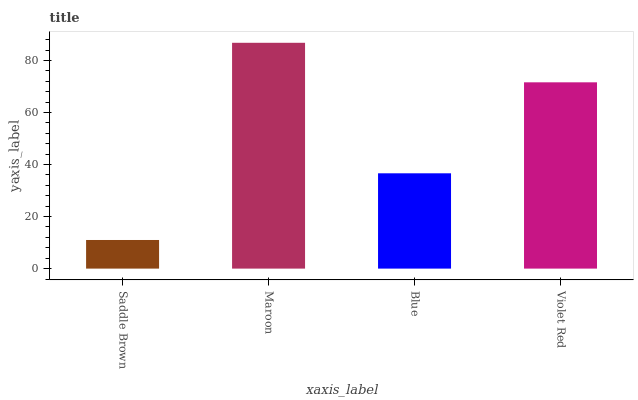Is Blue the minimum?
Answer yes or no. No. Is Blue the maximum?
Answer yes or no. No. Is Maroon greater than Blue?
Answer yes or no. Yes. Is Blue less than Maroon?
Answer yes or no. Yes. Is Blue greater than Maroon?
Answer yes or no. No. Is Maroon less than Blue?
Answer yes or no. No. Is Violet Red the high median?
Answer yes or no. Yes. Is Blue the low median?
Answer yes or no. Yes. Is Blue the high median?
Answer yes or no. No. Is Saddle Brown the low median?
Answer yes or no. No. 